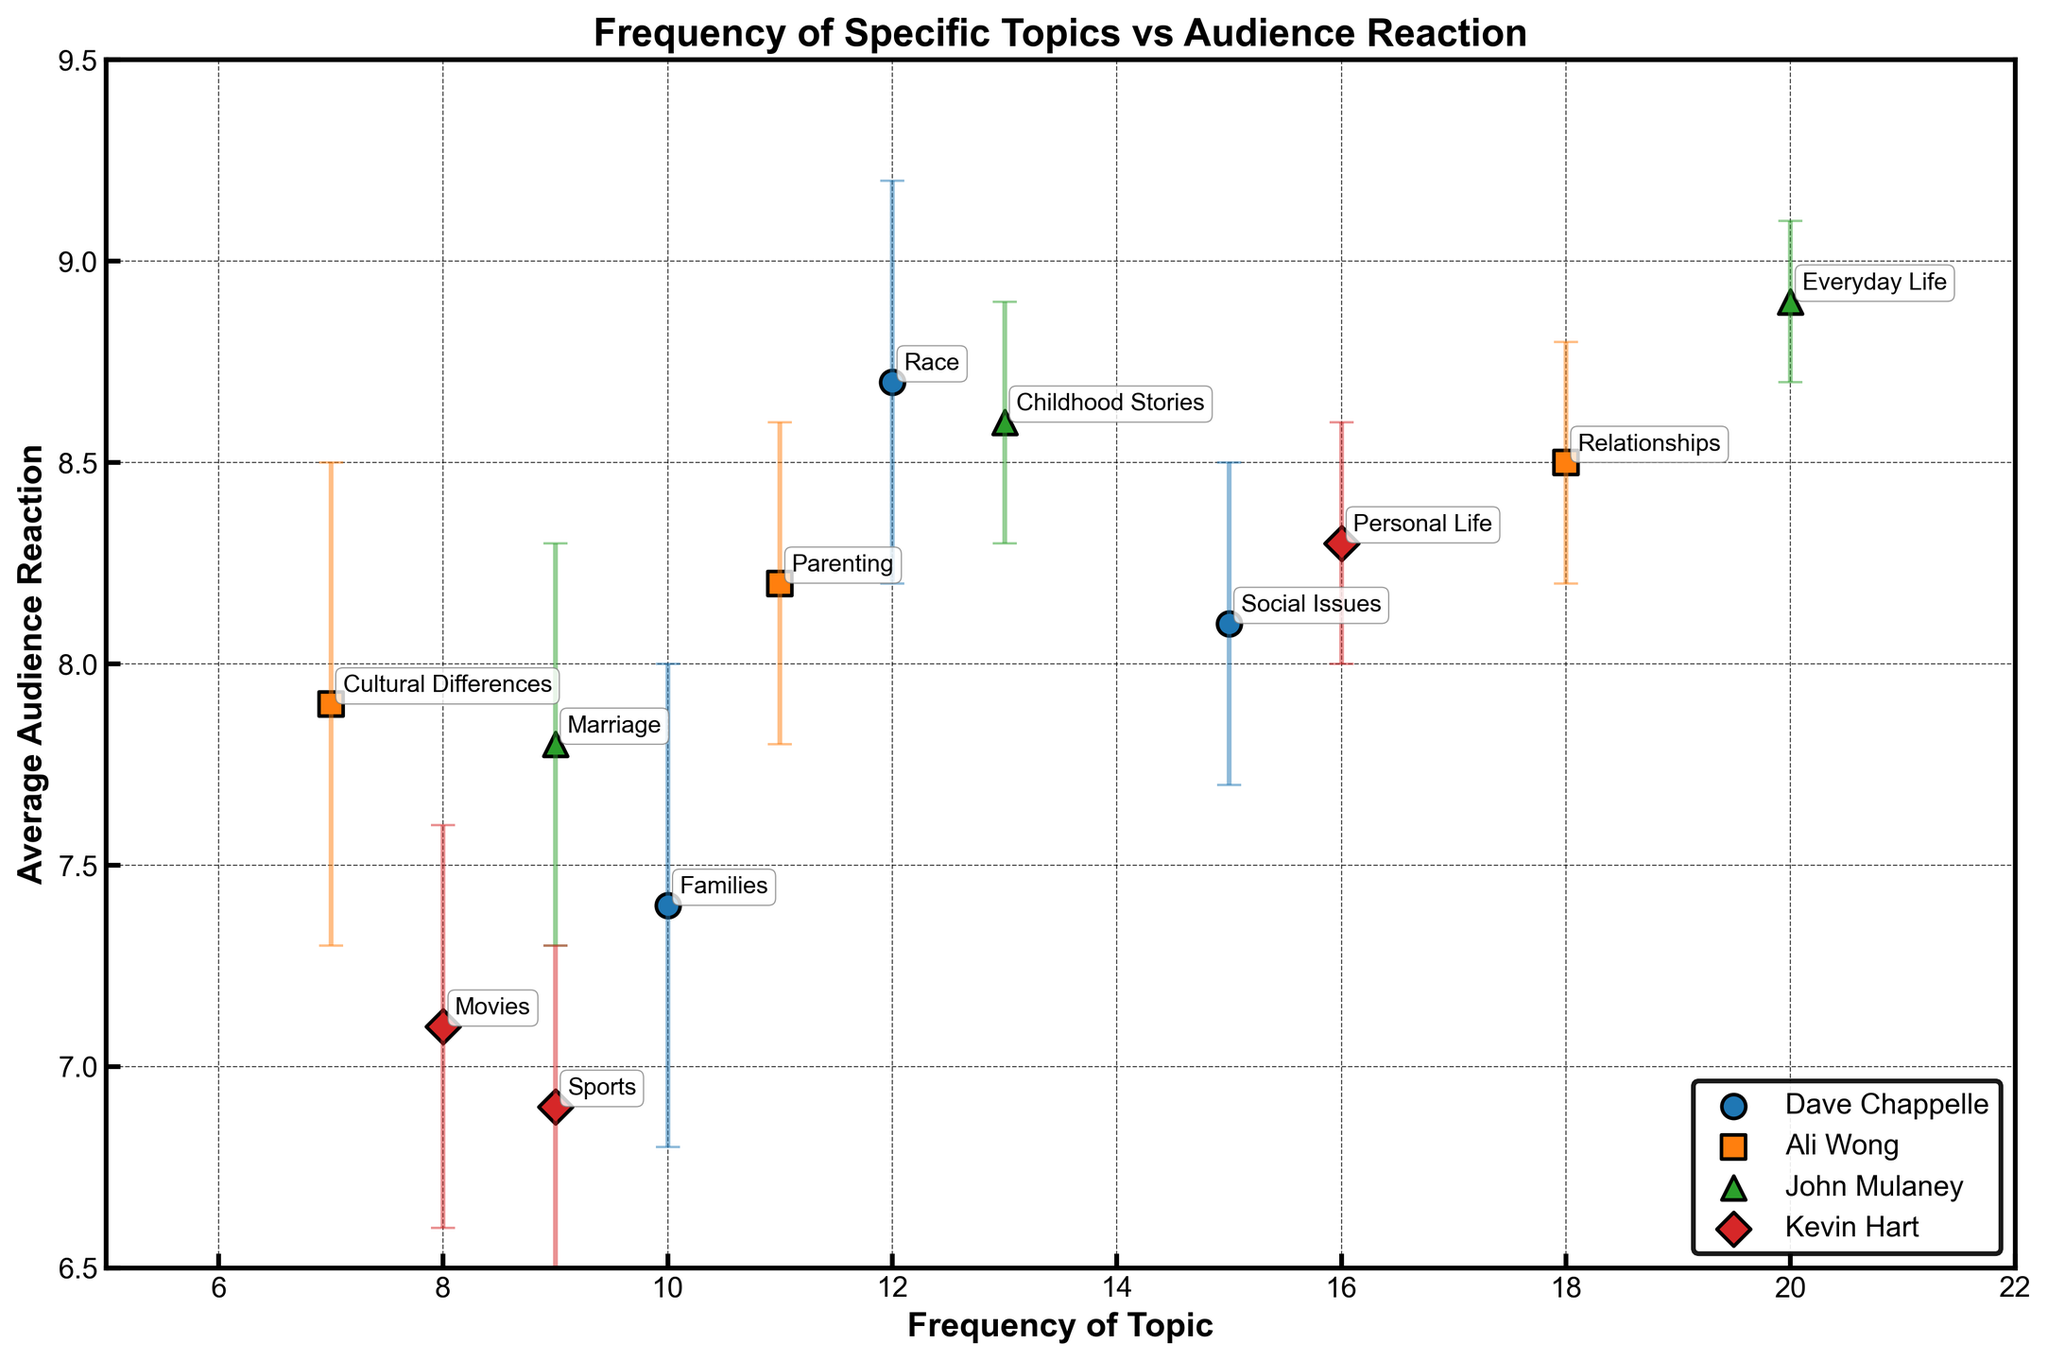what is the title of the plot? The title of the plot is written at the top center of the figure. It specifies what the plot is about.
Answer: Frequency of Specific Topics vs Audience Reaction Which comedian discusses ‘Relationships’ most frequently? By looking at the data points labeled by comedian names and corresponding topics, ‘Relationships’ appears most frequently in Ali Wong’s set.
Answer: Ali Wong How many topics does John Mulaney have in the plot? Each comedian has multiple topics, and we can count the unique topics for each. John Mulaney has three distinct topics shown in the plot: Everyday Life, Childhood Stories, and Marriage.
Answer: 3 Which topic has the highest average audience reaction and who is the comedian? The y-axis represents the average audience reaction. The data point with the highest y-value will have the highest reaction. John Mulaney’s ‘Everyday Life’ has an average reaction of 8.9, the highest on the plot.
Answer: Everyday Life, John Mulaney What is the smallest standard error of reaction for any topic? Standard error is represented by the error bars. The smallest error bars indicate the smallest standard error. John Mulaney’s ‘Everyday Life’ has the smallest standard error of 0.2.
Answer: 0.2 Who has more frequency discussing ‘Families’, Dave Chappelle or Kevin Hart? Compare the frequency values on the x-axis for the topics under each comedian. Dave Chappelle discusses ‘Families’ with a frequency of 10, while Kevin Hart doesn’t discuss 'Families'.
Answer: Dave Chappelle What is the average audience reaction for Kevin Hart's topic ‘Personal Life’? Identify the data point for Kevin Hart’s ‘Personal Life’ and read the corresponding y-value. The average audience reaction is 8.3.
Answer: 8.3 Which comedian has the biggest range in average audience reactions across their topics? Calculate the range (difference between highest and lowest) for each comedian. Dave Chappelle has the biggest range, from ‘Race’ with 8.7 to ‘Families’ with 7.4.
Answer: Dave Chappelle Between Ali Wong and Dave Chappelle, who has a topic with a higher audience reaction? Compare the highest audience reactions of both comedians. Dave Chappelle’s highest is 8.7 (Race), while Ali Wong’s highest is 8.5 (Relationships).
Answer: Dave Chappelle Which topic has the lowest frequency but still maintains a high average audience reaction? Identify the topic with the smallest x-value and then check its y-value to ensure it’s high. ‘Cultural Differences’ by Ali Wong has a frequency of 7 and maintains an average reaction of 7.9.
Answer: Cultural Differences, Ali Wong 